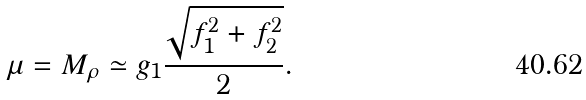<formula> <loc_0><loc_0><loc_500><loc_500>\mu = M _ { \rho } \simeq g _ { 1 } \frac { \sqrt { f _ { 1 } ^ { 2 } + f _ { 2 } ^ { 2 } } } { 2 } .</formula> 